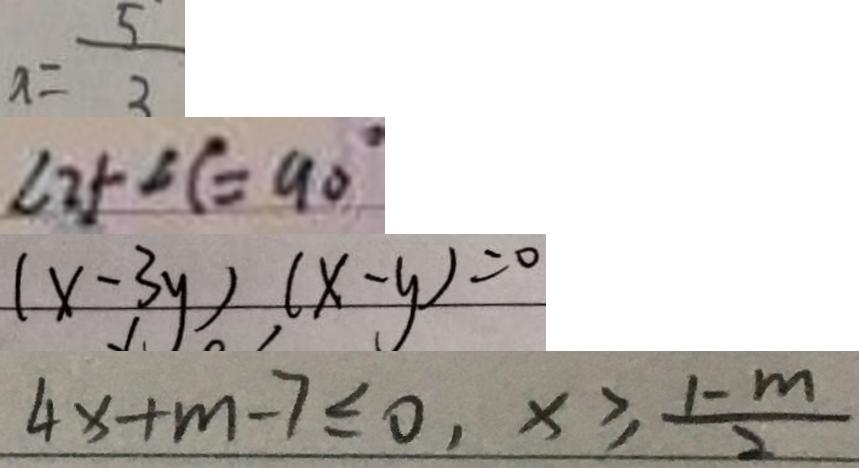<formula> <loc_0><loc_0><loc_500><loc_500>x = \frac { 5 } { 3 } 
 \angle 2 + \angle C = 9 0 ^ { \circ } 
 ( x - 3 y ) ( x - y ) = 0 
 4 x + m - 7 \leq 0 , x \geq \frac { 1 - m } { 2 }</formula> 